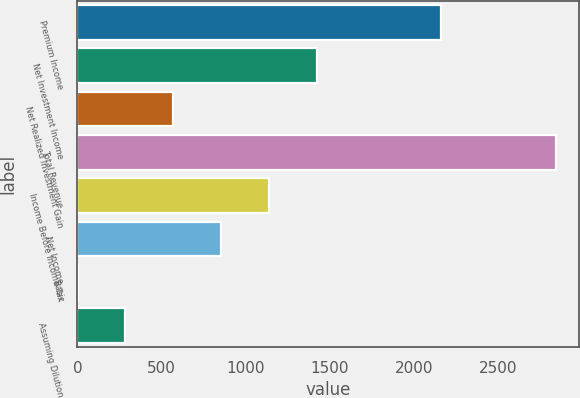Convert chart. <chart><loc_0><loc_0><loc_500><loc_500><bar_chart><fcel>Premium Income<fcel>Net Investment Income<fcel>Net Realized Investment Gain<fcel>Total Revenue<fcel>Income Before Income Tax<fcel>Net Income<fcel>Basic<fcel>Assuming Dilution<nl><fcel>2158.4<fcel>1420.19<fcel>568.79<fcel>2839.2<fcel>1136.39<fcel>852.59<fcel>1.19<fcel>284.99<nl></chart> 